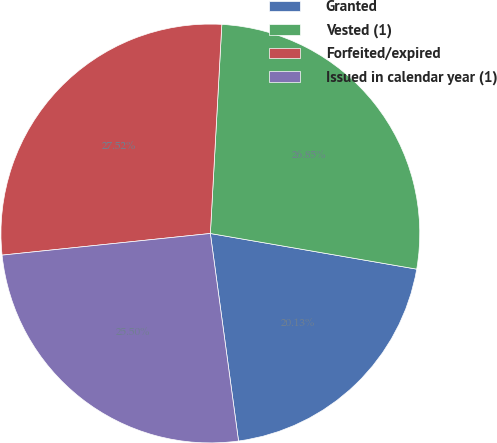Convert chart. <chart><loc_0><loc_0><loc_500><loc_500><pie_chart><fcel>Granted<fcel>Vested (1)<fcel>Forfeited/expired<fcel>Issued in calendar year (1)<nl><fcel>20.13%<fcel>26.85%<fcel>27.52%<fcel>25.5%<nl></chart> 